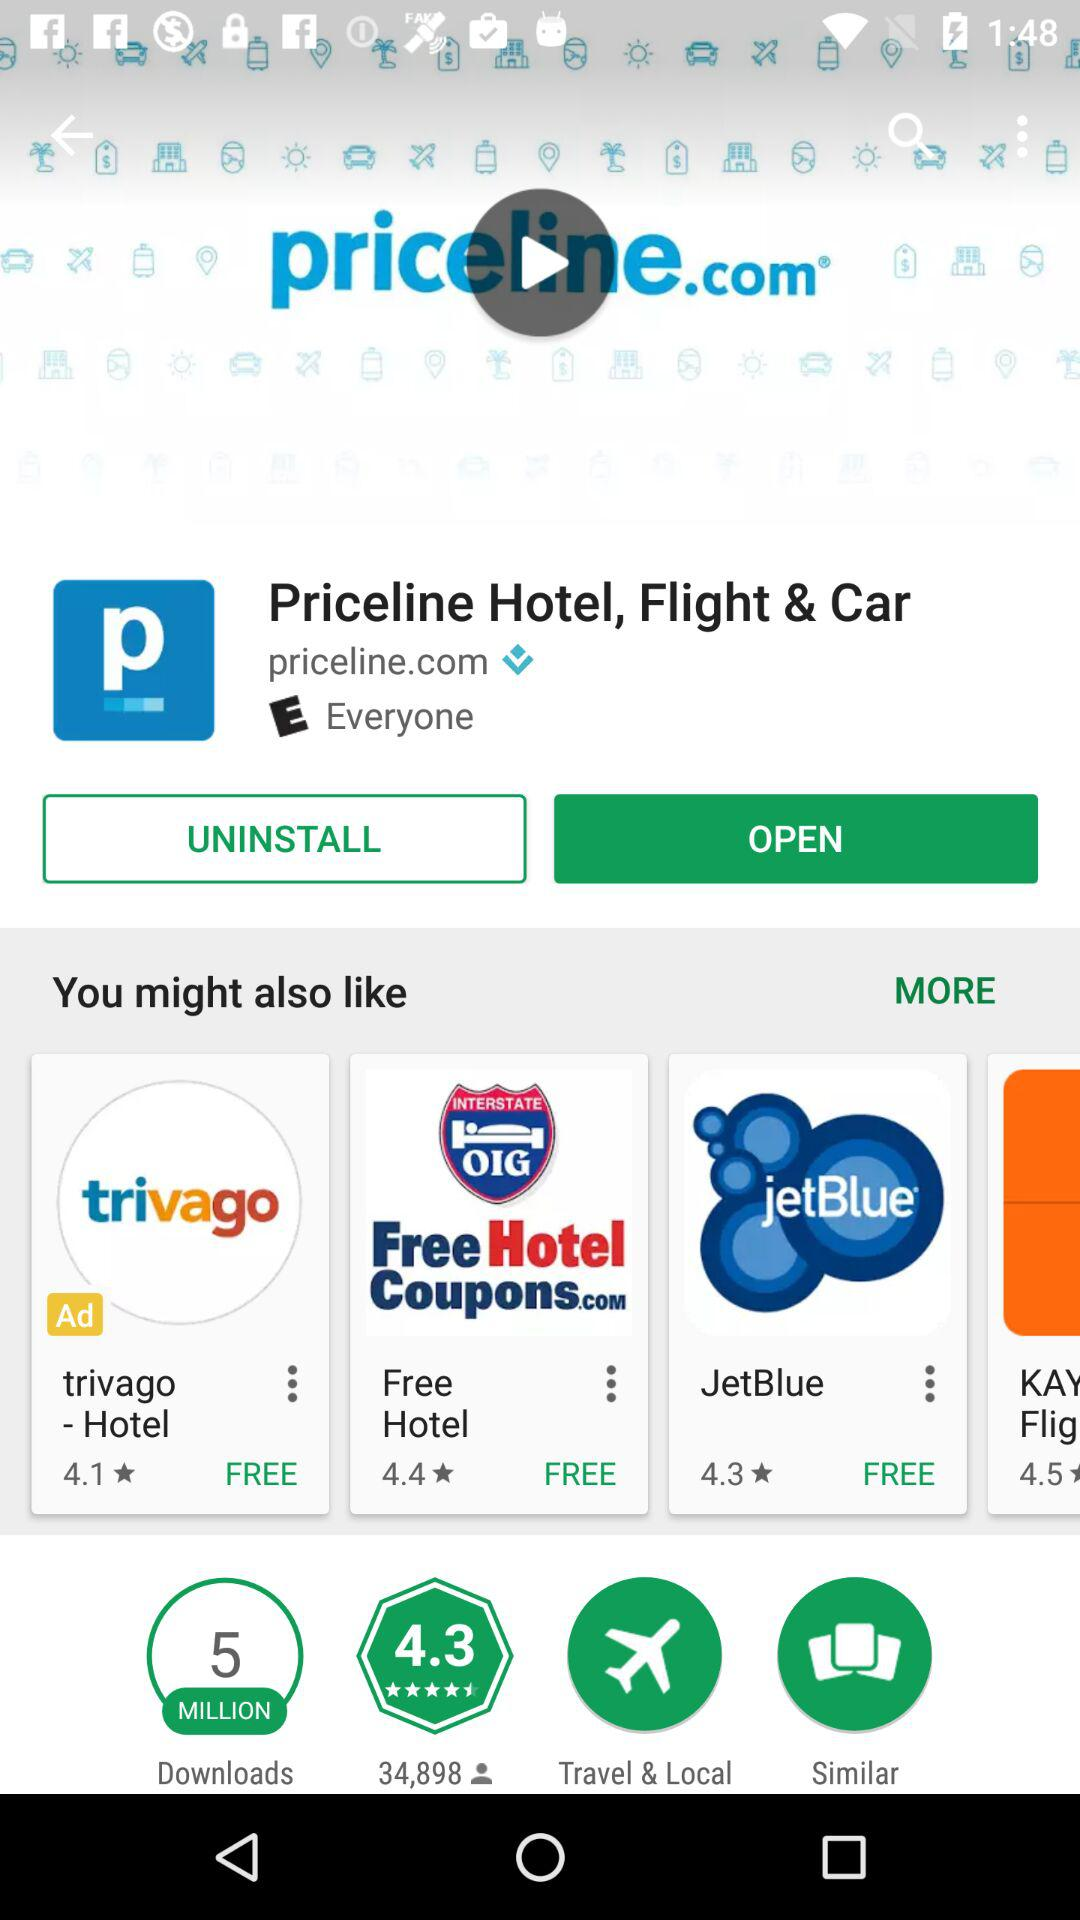How many downloads are there for Priceline hotels, flights, and cars? There are 5 million downloads for Priceline hotels, flights, and cars. 